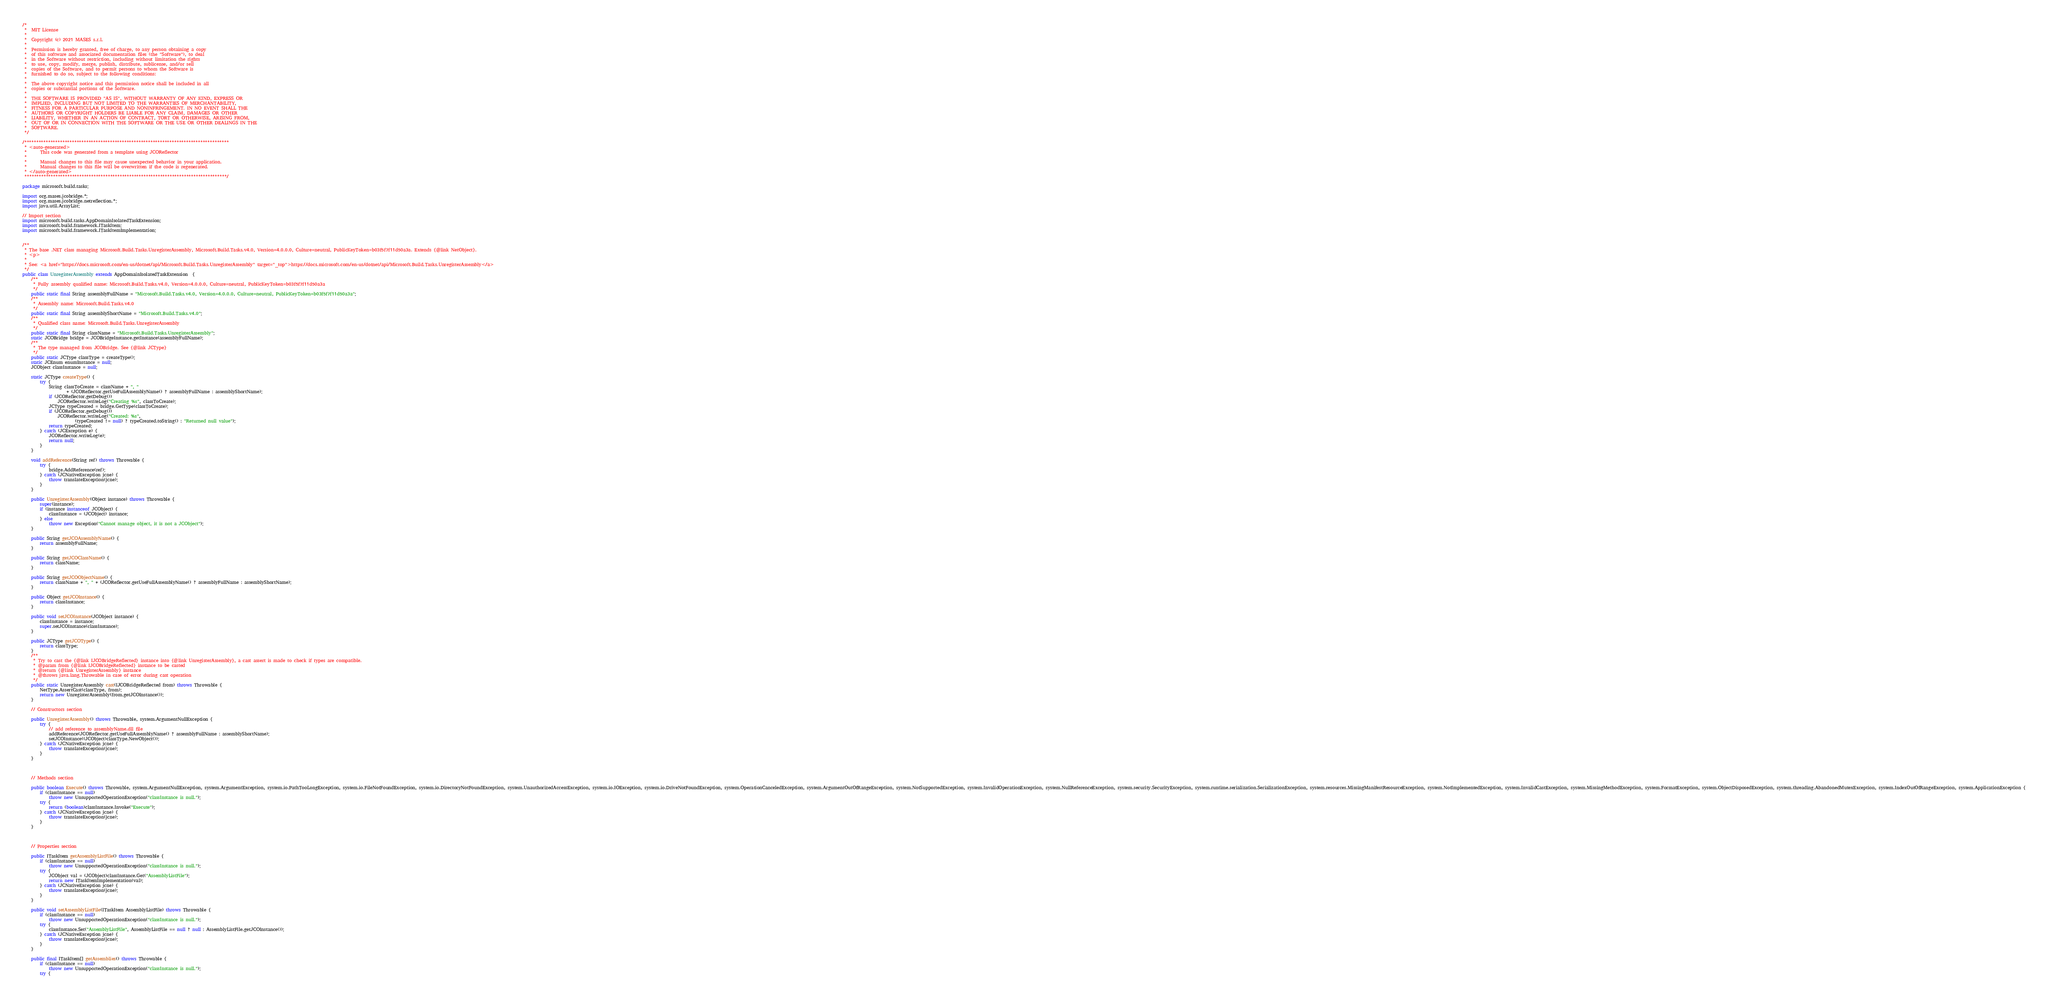<code> <loc_0><loc_0><loc_500><loc_500><_Java_>/*
 *  MIT License
 *
 *  Copyright (c) 2021 MASES s.r.l.
 *
 *  Permission is hereby granted, free of charge, to any person obtaining a copy
 *  of this software and associated documentation files (the "Software"), to deal
 *  in the Software without restriction, including without limitation the rights
 *  to use, copy, modify, merge, publish, distribute, sublicense, and/or sell
 *  copies of the Software, and to permit persons to whom the Software is
 *  furnished to do so, subject to the following conditions:
 *
 *  The above copyright notice and this permission notice shall be included in all
 *  copies or substantial portions of the Software.
 *
 *  THE SOFTWARE IS PROVIDED "AS IS", WITHOUT WARRANTY OF ANY KIND, EXPRESS OR
 *  IMPLIED, INCLUDING BUT NOT LIMITED TO THE WARRANTIES OF MERCHANTABILITY,
 *  FITNESS FOR A PARTICULAR PURPOSE AND NONINFRINGEMENT. IN NO EVENT SHALL THE
 *  AUTHORS OR COPYRIGHT HOLDERS BE LIABLE FOR ANY CLAIM, DAMAGES OR OTHER
 *  LIABILITY, WHETHER IN AN ACTION OF CONTRACT, TORT OR OTHERWISE, ARISING FROM,
 *  OUT OF OR IN CONNECTION WITH THE SOFTWARE OR THE USE OR OTHER DEALINGS IN THE
 *  SOFTWARE.
 */

/**************************************************************************************
 * <auto-generated>
 *      This code was generated from a template using JCOReflector
 * 
 *      Manual changes to this file may cause unexpected behavior in your application.
 *      Manual changes to this file will be overwritten if the code is regenerated.
 * </auto-generated>
 *************************************************************************************/

package microsoft.build.tasks;

import org.mases.jcobridge.*;
import org.mases.jcobridge.netreflection.*;
import java.util.ArrayList;

// Import section
import microsoft.build.tasks.AppDomainIsolatedTaskExtension;
import microsoft.build.framework.ITaskItem;
import microsoft.build.framework.ITaskItemImplementation;


/**
 * The base .NET class managing Microsoft.Build.Tasks.UnregisterAssembly, Microsoft.Build.Tasks.v4.0, Version=4.0.0.0, Culture=neutral, PublicKeyToken=b03f5f7f11d50a3a. Extends {@link NetObject}.
 * <p>
 * 
 * See: <a href="https://docs.microsoft.com/en-us/dotnet/api/Microsoft.Build.Tasks.UnregisterAssembly" target="_top">https://docs.microsoft.com/en-us/dotnet/api/Microsoft.Build.Tasks.UnregisterAssembly</a>
 */
public class UnregisterAssembly extends AppDomainIsolatedTaskExtension  {
    /**
     * Fully assembly qualified name: Microsoft.Build.Tasks.v4.0, Version=4.0.0.0, Culture=neutral, PublicKeyToken=b03f5f7f11d50a3a
     */
    public static final String assemblyFullName = "Microsoft.Build.Tasks.v4.0, Version=4.0.0.0, Culture=neutral, PublicKeyToken=b03f5f7f11d50a3a";
    /**
     * Assembly name: Microsoft.Build.Tasks.v4.0
     */
    public static final String assemblyShortName = "Microsoft.Build.Tasks.v4.0";
    /**
     * Qualified class name: Microsoft.Build.Tasks.UnregisterAssembly
     */
    public static final String className = "Microsoft.Build.Tasks.UnregisterAssembly";
    static JCOBridge bridge = JCOBridgeInstance.getInstance(assemblyFullName);
    /**
     * The type managed from JCOBridge. See {@link JCType}
     */
    public static JCType classType = createType();
    static JCEnum enumInstance = null;
    JCObject classInstance = null;

    static JCType createType() {
        try {
            String classToCreate = className + ", "
                    + (JCOReflector.getUseFullAssemblyName() ? assemblyFullName : assemblyShortName);
            if (JCOReflector.getDebug())
                JCOReflector.writeLog("Creating %s", classToCreate);
            JCType typeCreated = bridge.GetType(classToCreate);
            if (JCOReflector.getDebug())
                JCOReflector.writeLog("Created: %s",
                        (typeCreated != null) ? typeCreated.toString() : "Returned null value");
            return typeCreated;
        } catch (JCException e) {
            JCOReflector.writeLog(e);
            return null;
        }
    }

    void addReference(String ref) throws Throwable {
        try {
            bridge.AddReference(ref);
        } catch (JCNativeException jcne) {
            throw translateException(jcne);
        }
    }

    public UnregisterAssembly(Object instance) throws Throwable {
        super(instance);
        if (instance instanceof JCObject) {
            classInstance = (JCObject) instance;
        } else
            throw new Exception("Cannot manage object, it is not a JCObject");
    }

    public String getJCOAssemblyName() {
        return assemblyFullName;
    }

    public String getJCOClassName() {
        return className;
    }

    public String getJCOObjectName() {
        return className + ", " + (JCOReflector.getUseFullAssemblyName() ? assemblyFullName : assemblyShortName);
    }

    public Object getJCOInstance() {
        return classInstance;
    }

    public void setJCOInstance(JCObject instance) {
        classInstance = instance;
        super.setJCOInstance(classInstance);
    }

    public JCType getJCOType() {
        return classType;
    }
    /**
     * Try to cast the {@link IJCOBridgeReflected} instance into {@link UnregisterAssembly}, a cast assert is made to check if types are compatible.
     * @param from {@link IJCOBridgeReflected} instance to be casted
     * @return {@link UnregisterAssembly} instance
     * @throws java.lang.Throwable in case of error during cast operation
     */
    public static UnregisterAssembly cast(IJCOBridgeReflected from) throws Throwable {
        NetType.AssertCast(classType, from);
        return new UnregisterAssembly(from.getJCOInstance());
    }

    // Constructors section
    
    public UnregisterAssembly() throws Throwable, system.ArgumentNullException {
        try {
            // add reference to assemblyName.dll file
            addReference(JCOReflector.getUseFullAssemblyName() ? assemblyFullName : assemblyShortName);
            setJCOInstance((JCObject)classType.NewObject());
        } catch (JCNativeException jcne) {
            throw translateException(jcne);
        }
    }


    
    // Methods section
    
    public boolean Execute() throws Throwable, system.ArgumentNullException, system.ArgumentException, system.io.PathTooLongException, system.io.FileNotFoundException, system.io.DirectoryNotFoundException, system.UnauthorizedAccessException, system.io.IOException, system.io.DriveNotFoundException, system.OperationCanceledException, system.ArgumentOutOfRangeException, system.NotSupportedException, system.InvalidOperationException, system.NullReferenceException, system.security.SecurityException, system.runtime.serialization.SerializationException, system.resources.MissingManifestResourceException, system.NotImplementedException, system.InvalidCastException, system.MissingMethodException, system.FormatException, system.ObjectDisposedException, system.threading.AbandonedMutexException, system.IndexOutOfRangeException, system.ApplicationException {
        if (classInstance == null)
            throw new UnsupportedOperationException("classInstance is null.");
        try {
            return (boolean)classInstance.Invoke("Execute");
        } catch (JCNativeException jcne) {
            throw translateException(jcne);
        }
    }


    
    // Properties section
    
    public ITaskItem getAssemblyListFile() throws Throwable {
        if (classInstance == null)
            throw new UnsupportedOperationException("classInstance is null.");
        try {
            JCObject val = (JCObject)classInstance.Get("AssemblyListFile");
            return new ITaskItemImplementation(val);
        } catch (JCNativeException jcne) {
            throw translateException(jcne);
        }
    }

    public void setAssemblyListFile(ITaskItem AssemblyListFile) throws Throwable {
        if (classInstance == null)
            throw new UnsupportedOperationException("classInstance is null.");
        try {
            classInstance.Set("AssemblyListFile", AssemblyListFile == null ? null : AssemblyListFile.getJCOInstance());
        } catch (JCNativeException jcne) {
            throw translateException(jcne);
        }
    }

    public final ITaskItem[] getAssemblies() throws Throwable {
        if (classInstance == null)
            throw new UnsupportedOperationException("classInstance is null.");
        try {</code> 